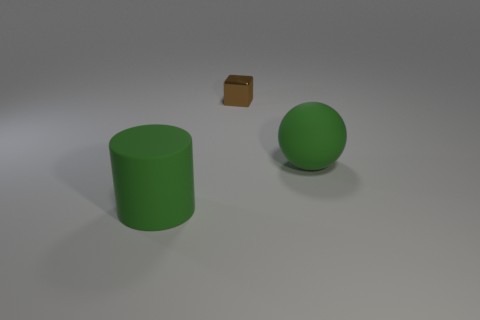Can you infer the potential scale of these objects? Without a reference object of known size, it is challenging to determine the absolute scale. However, based on the relative sizes to each other, one might guess the objects are similar in size to everyday items such as a cylinder that could be a large cup, a sphere resembling a small ball, and a small metal block reminiscent of a dice. 